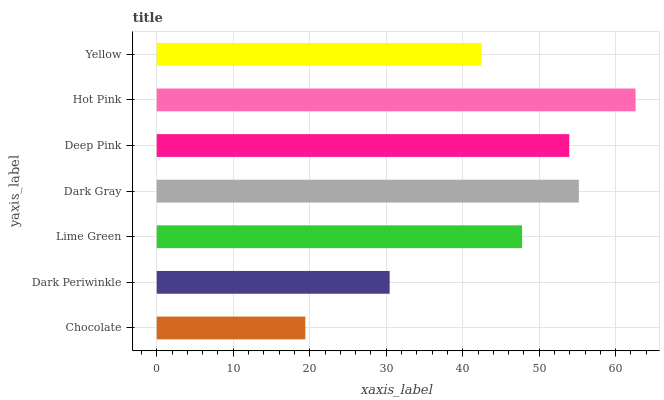Is Chocolate the minimum?
Answer yes or no. Yes. Is Hot Pink the maximum?
Answer yes or no. Yes. Is Dark Periwinkle the minimum?
Answer yes or no. No. Is Dark Periwinkle the maximum?
Answer yes or no. No. Is Dark Periwinkle greater than Chocolate?
Answer yes or no. Yes. Is Chocolate less than Dark Periwinkle?
Answer yes or no. Yes. Is Chocolate greater than Dark Periwinkle?
Answer yes or no. No. Is Dark Periwinkle less than Chocolate?
Answer yes or no. No. Is Lime Green the high median?
Answer yes or no. Yes. Is Lime Green the low median?
Answer yes or no. Yes. Is Chocolate the high median?
Answer yes or no. No. Is Dark Periwinkle the low median?
Answer yes or no. No. 